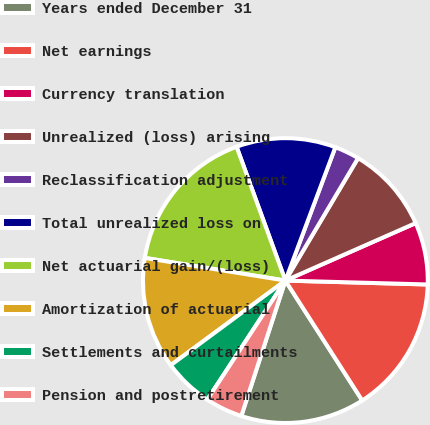Convert chart. <chart><loc_0><loc_0><loc_500><loc_500><pie_chart><fcel>Years ended December 31<fcel>Net earnings<fcel>Currency translation<fcel>Unrealized (loss) arising<fcel>Reclassification adjustment<fcel>Total unrealized loss on<fcel>Net actuarial gain/(loss)<fcel>Amortization of actuarial<fcel>Settlements and curtailments<fcel>Pension and postretirement<nl><fcel>14.08%<fcel>15.49%<fcel>7.05%<fcel>9.86%<fcel>2.82%<fcel>11.27%<fcel>16.89%<fcel>12.67%<fcel>5.64%<fcel>4.23%<nl></chart> 